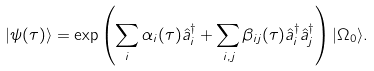Convert formula to latex. <formula><loc_0><loc_0><loc_500><loc_500>| \psi ( \tau ) \rangle = \exp \left ( \sum _ { i } \alpha _ { i } ( \tau ) \hat { a } _ { i } ^ { \dagger } + \sum _ { i , j } \beta _ { i j } ( \tau ) \hat { a } _ { i } ^ { \dagger } \hat { a } _ { j } ^ { \dagger } \right ) | \Omega _ { 0 } \rangle .</formula> 